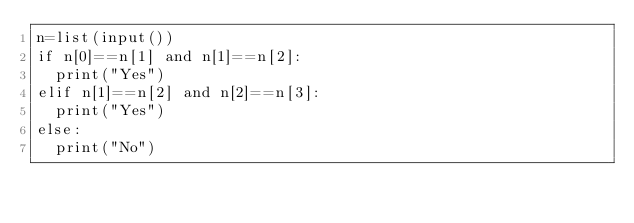<code> <loc_0><loc_0><loc_500><loc_500><_Python_>n=list(input())
if n[0]==n[1] and n[1]==n[2]:
  print("Yes")
elif n[1]==n[2] and n[2]==n[3]:
  print("Yes")
else:
  print("No")</code> 